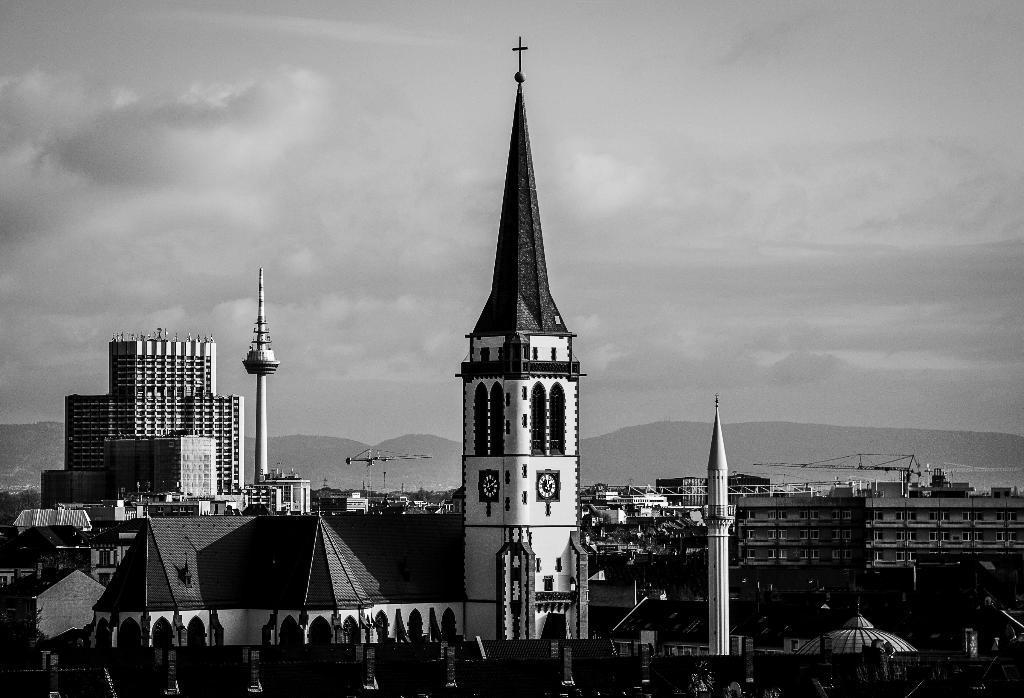How would you summarize this image in a sentence or two? In this picture there is a church in the center of the image and there are buildings in the image. 